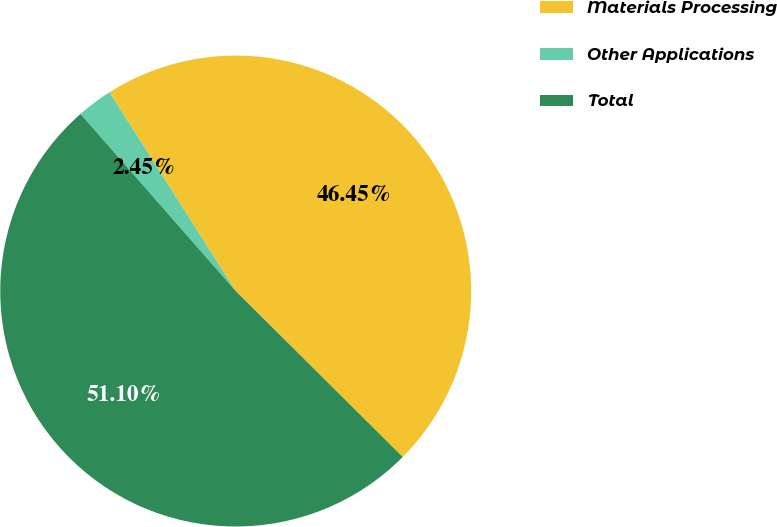Convert chart to OTSL. <chart><loc_0><loc_0><loc_500><loc_500><pie_chart><fcel>Materials Processing<fcel>Other Applications<fcel>Total<nl><fcel>46.45%<fcel>2.45%<fcel>51.1%<nl></chart> 